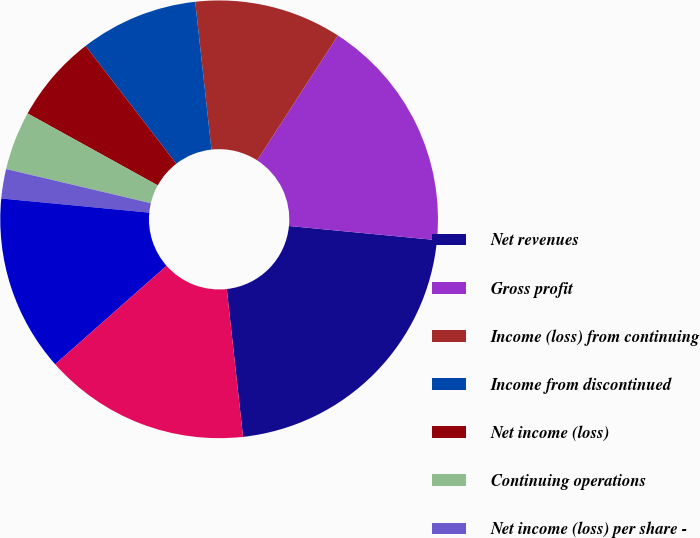Convert chart. <chart><loc_0><loc_0><loc_500><loc_500><pie_chart><fcel>Net revenues<fcel>Gross profit<fcel>Income (loss) from continuing<fcel>Income from discontinued<fcel>Net income (loss)<fcel>Continuing operations<fcel>Net income (loss) per share -<fcel>Basic<fcel>Diluted<nl><fcel>21.74%<fcel>17.39%<fcel>10.87%<fcel>8.7%<fcel>6.52%<fcel>4.35%<fcel>2.17%<fcel>13.04%<fcel>15.22%<nl></chart> 